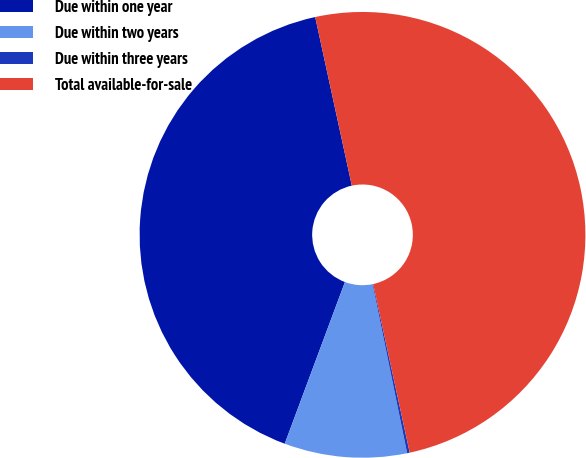Convert chart to OTSL. <chart><loc_0><loc_0><loc_500><loc_500><pie_chart><fcel>Due within one year<fcel>Due within two years<fcel>Due within three years<fcel>Total available-for-sale<nl><fcel>40.92%<fcel>8.88%<fcel>0.19%<fcel>50.0%<nl></chart> 